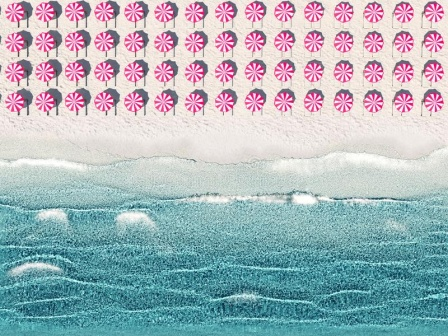Can you create a short and realistic scenario for this beach scene? Sure! A family arrives at this serene beach on a sunny afternoon, setting up their umbrellas (which incidentally look like those pink and white peppermint shapes in the sky) near the water's edge. The parents relax on their beach chairs while the children play by the ocean, their laughter mingling with the sound of the waves. They build sandcastles, digging their toes into the textured sand, occasionally running to the water to cool off. The rhythmic waves, depicted by the blue lines in the image, quietly roll in, providing a soothing background symphony. 